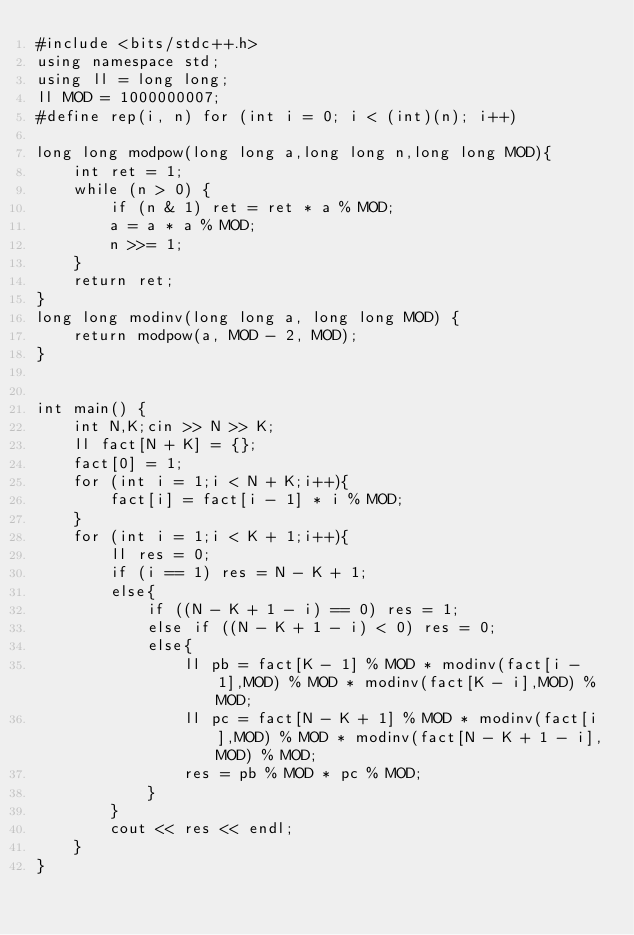Convert code to text. <code><loc_0><loc_0><loc_500><loc_500><_C++_>#include <bits/stdc++.h>
using namespace std;
using ll = long long;
ll MOD = 1000000007;
#define rep(i, n) for (int i = 0; i < (int)(n); i++)

long long modpow(long long a,long long n,long long MOD){
    int ret = 1;
    while (n > 0) {
        if (n & 1) ret = ret * a % MOD;
        a = a * a % MOD;
        n >>= 1;
    }
    return ret;
}
long long modinv(long long a, long long MOD) {
    return modpow(a, MOD - 2, MOD);
}


int main() {
    int N,K;cin >> N >> K;
    ll fact[N + K] = {};
    fact[0] = 1;
    for (int i = 1;i < N + K;i++){
        fact[i] = fact[i - 1] * i % MOD;
    }
    for (int i = 1;i < K + 1;i++){
        ll res = 0;
        if (i == 1) res = N - K + 1;
        else{
            if ((N - K + 1 - i) == 0) res = 1;
            else if ((N - K + 1 - i) < 0) res = 0;
            else{
                ll pb = fact[K - 1] % MOD * modinv(fact[i - 1],MOD) % MOD * modinv(fact[K - i],MOD) % MOD;
                ll pc = fact[N - K + 1] % MOD * modinv(fact[i],MOD) % MOD * modinv(fact[N - K + 1 - i],MOD) % MOD;
                res = pb % MOD * pc % MOD;
            }
        }
        cout << res << endl;
    }
}</code> 